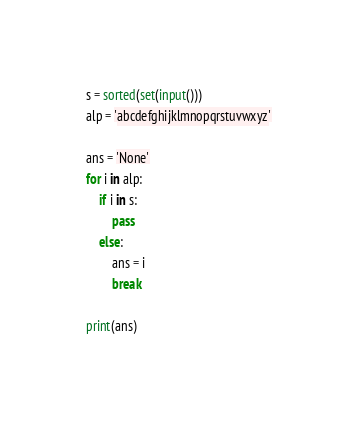<code> <loc_0><loc_0><loc_500><loc_500><_Python_>s = sorted(set(input()))
alp = 'abcdefghijklmnopqrstuvwxyz'

ans = 'None'
for i in alp:
    if i in s:
        pass
    else:
        ans = i
        break

print(ans)</code> 